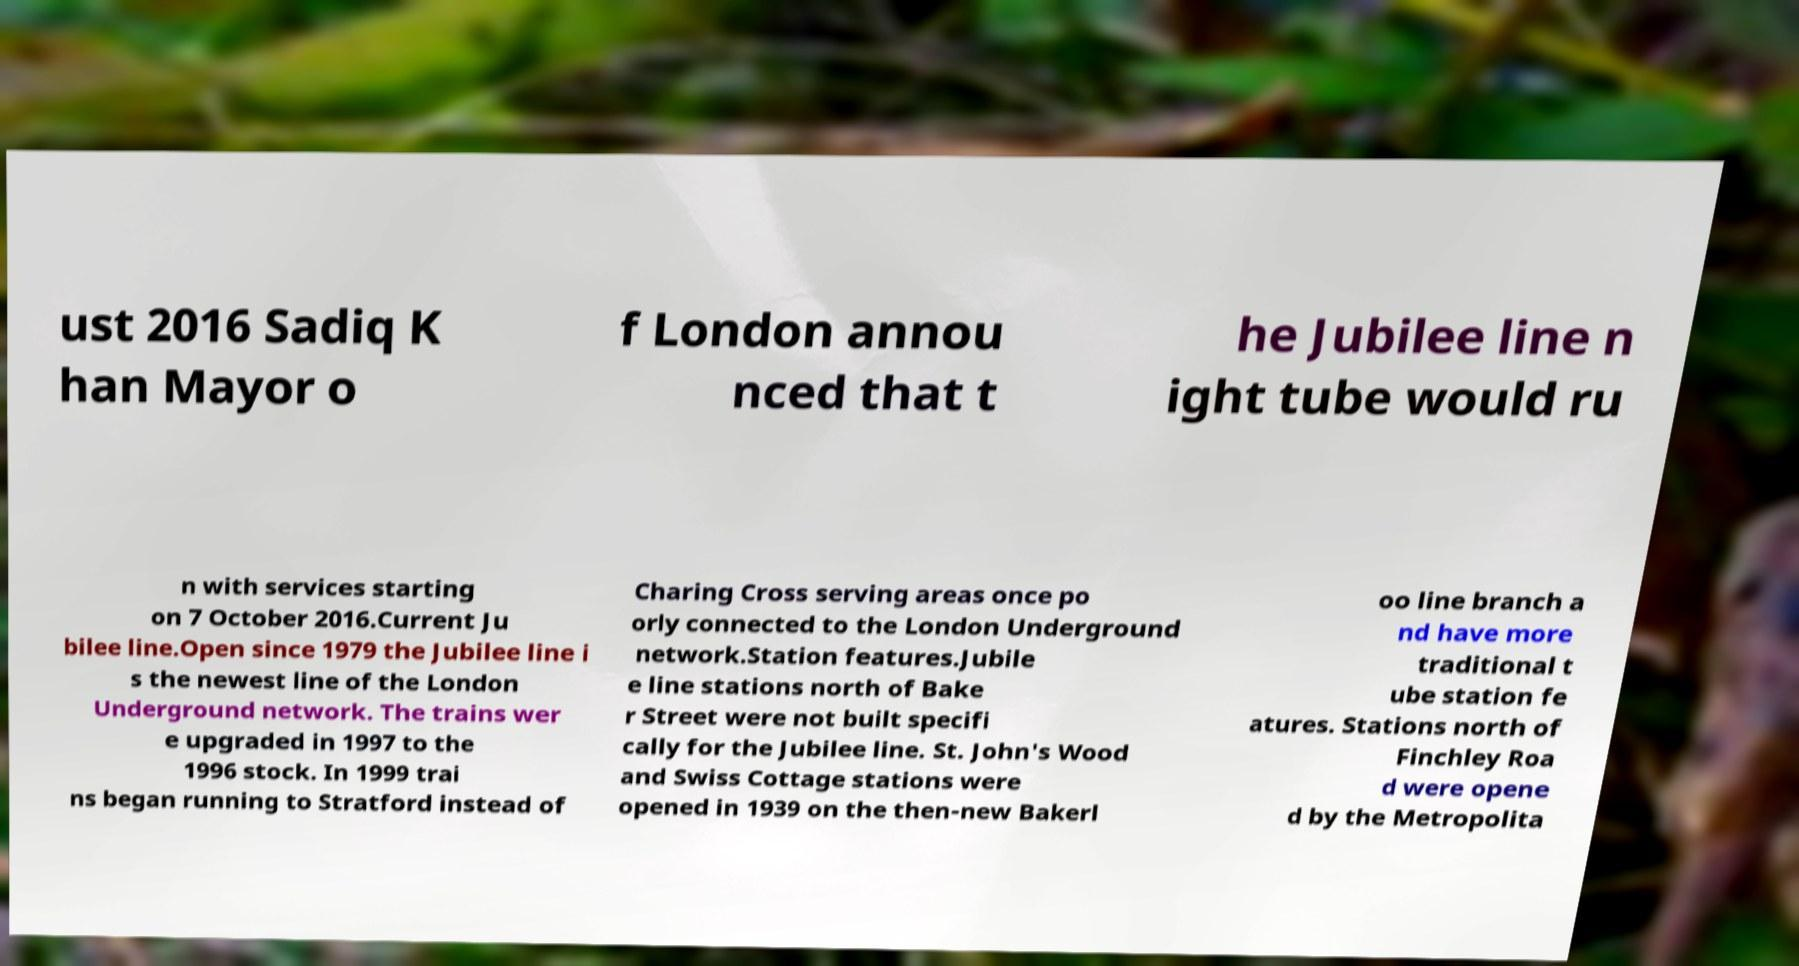Can you read and provide the text displayed in the image?This photo seems to have some interesting text. Can you extract and type it out for me? ust 2016 Sadiq K han Mayor o f London annou nced that t he Jubilee line n ight tube would ru n with services starting on 7 October 2016.Current Ju bilee line.Open since 1979 the Jubilee line i s the newest line of the London Underground network. The trains wer e upgraded in 1997 to the 1996 stock. In 1999 trai ns began running to Stratford instead of Charing Cross serving areas once po orly connected to the London Underground network.Station features.Jubile e line stations north of Bake r Street were not built specifi cally for the Jubilee line. St. John's Wood and Swiss Cottage stations were opened in 1939 on the then-new Bakerl oo line branch a nd have more traditional t ube station fe atures. Stations north of Finchley Roa d were opene d by the Metropolita 